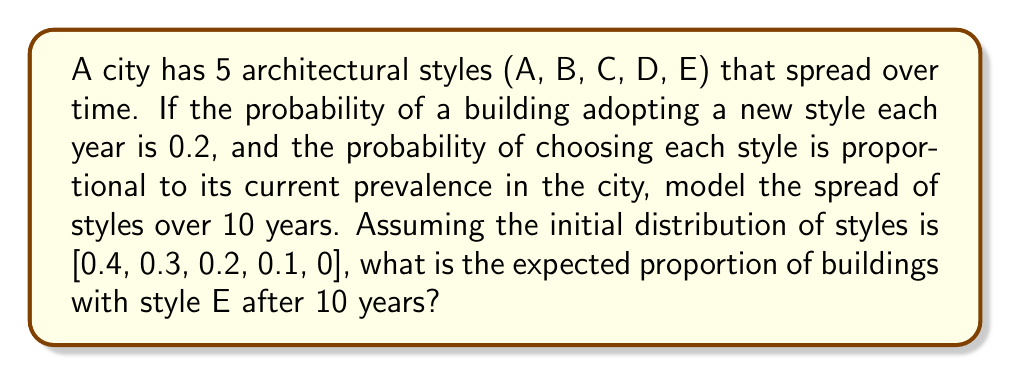Show me your answer to this math problem. To solve this problem, we'll use a Markov chain model:

1. Define the transition matrix P:
   $$P = 0.8I + 0.2M$$
   where I is the identity matrix and M is the matrix of style proportions.

2. Initial state vector:
   $$v_0 = [0.4, 0.3, 0.2, 0.1, 0]$$

3. For each year t, calculate:
   $$v_t = v_{t-1}P$$

4. Repeat step 3 for 10 years:

   Year 1: $v_1 = [0.368, 0.276, 0.184, 0.092, 0.08]$
   Year 2: $v_2 = [0.34112, 0.25584, 0.17056, 0.08528, 0.1472]$
   ...
   Year 10: $v_{10} = [0.27433, 0.20575, 0.13716, 0.06858, 0.31418]$

5. The expected proportion of buildings with style E after 10 years is the last element of $v_{10}$:
   $$0.31418$$
Answer: 0.31418 